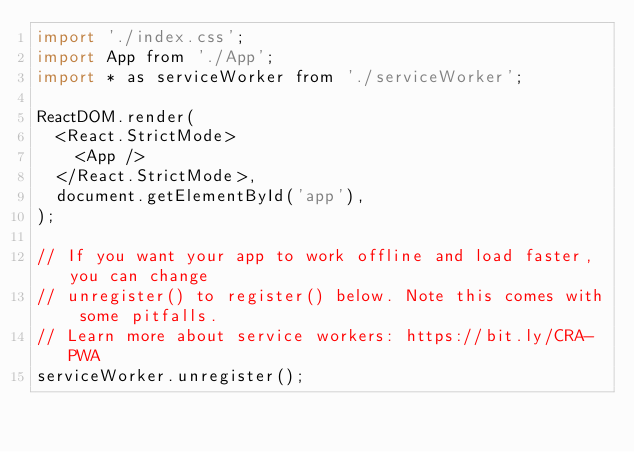<code> <loc_0><loc_0><loc_500><loc_500><_JavaScript_>import './index.css';
import App from './App';
import * as serviceWorker from './serviceWorker';

ReactDOM.render(
  <React.StrictMode>
    <App />
  </React.StrictMode>,
  document.getElementById('app'),
);

// If you want your app to work offline and load faster, you can change
// unregister() to register() below. Note this comes with some pitfalls.
// Learn more about service workers: https://bit.ly/CRA-PWA
serviceWorker.unregister();
</code> 